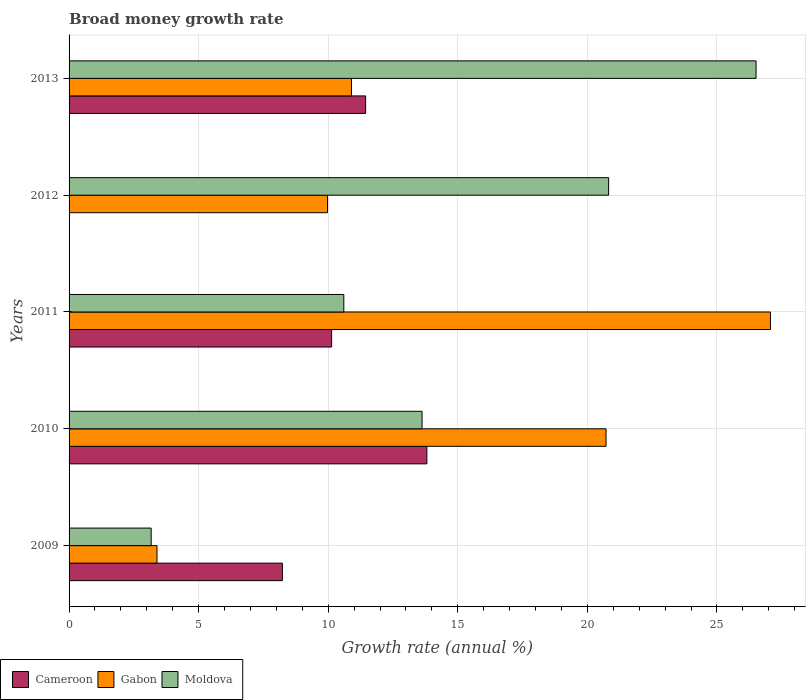How many groups of bars are there?
Keep it short and to the point. 5. Are the number of bars on each tick of the Y-axis equal?
Offer a very short reply. No. How many bars are there on the 5th tick from the top?
Your answer should be very brief. 3. What is the growth rate in Gabon in 2011?
Give a very brief answer. 27.07. Across all years, what is the maximum growth rate in Moldova?
Offer a terse response. 26.51. Across all years, what is the minimum growth rate in Moldova?
Your answer should be compact. 3.17. In which year was the growth rate in Cameroon maximum?
Offer a very short reply. 2010. What is the total growth rate in Gabon in the graph?
Your answer should be very brief. 72.05. What is the difference between the growth rate in Gabon in 2009 and that in 2013?
Your answer should be compact. -7.5. What is the difference between the growth rate in Gabon in 2010 and the growth rate in Cameroon in 2012?
Provide a succinct answer. 20.72. What is the average growth rate in Moldova per year?
Provide a short and direct response. 14.94. In the year 2013, what is the difference between the growth rate in Gabon and growth rate in Cameroon?
Offer a very short reply. -0.55. What is the ratio of the growth rate in Gabon in 2010 to that in 2012?
Your answer should be very brief. 2.08. Is the growth rate in Moldova in 2011 less than that in 2012?
Offer a very short reply. Yes. Is the difference between the growth rate in Gabon in 2009 and 2011 greater than the difference between the growth rate in Cameroon in 2009 and 2011?
Provide a short and direct response. No. What is the difference between the highest and the second highest growth rate in Cameroon?
Ensure brevity in your answer.  2.36. What is the difference between the highest and the lowest growth rate in Cameroon?
Provide a succinct answer. 13.81. In how many years, is the growth rate in Moldova greater than the average growth rate in Moldova taken over all years?
Your answer should be compact. 2. Is it the case that in every year, the sum of the growth rate in Gabon and growth rate in Cameroon is greater than the growth rate in Moldova?
Give a very brief answer. No. How many years are there in the graph?
Your response must be concise. 5. Are the values on the major ticks of X-axis written in scientific E-notation?
Ensure brevity in your answer.  No. Does the graph contain any zero values?
Give a very brief answer. Yes. Does the graph contain grids?
Keep it short and to the point. Yes. Where does the legend appear in the graph?
Ensure brevity in your answer.  Bottom left. How many legend labels are there?
Offer a terse response. 3. What is the title of the graph?
Ensure brevity in your answer.  Broad money growth rate. What is the label or title of the X-axis?
Give a very brief answer. Growth rate (annual %). What is the Growth rate (annual %) of Cameroon in 2009?
Give a very brief answer. 8.23. What is the Growth rate (annual %) of Gabon in 2009?
Make the answer very short. 3.39. What is the Growth rate (annual %) of Moldova in 2009?
Offer a terse response. 3.17. What is the Growth rate (annual %) of Cameroon in 2010?
Your response must be concise. 13.81. What is the Growth rate (annual %) in Gabon in 2010?
Provide a short and direct response. 20.72. What is the Growth rate (annual %) of Moldova in 2010?
Make the answer very short. 13.62. What is the Growth rate (annual %) in Cameroon in 2011?
Your answer should be compact. 10.13. What is the Growth rate (annual %) of Gabon in 2011?
Offer a terse response. 27.07. What is the Growth rate (annual %) in Moldova in 2011?
Your answer should be very brief. 10.6. What is the Growth rate (annual %) of Cameroon in 2012?
Ensure brevity in your answer.  0. What is the Growth rate (annual %) of Gabon in 2012?
Ensure brevity in your answer.  9.97. What is the Growth rate (annual %) in Moldova in 2012?
Provide a succinct answer. 20.82. What is the Growth rate (annual %) of Cameroon in 2013?
Make the answer very short. 11.44. What is the Growth rate (annual %) in Gabon in 2013?
Provide a short and direct response. 10.9. What is the Growth rate (annual %) in Moldova in 2013?
Provide a succinct answer. 26.51. Across all years, what is the maximum Growth rate (annual %) of Cameroon?
Provide a short and direct response. 13.81. Across all years, what is the maximum Growth rate (annual %) in Gabon?
Your response must be concise. 27.07. Across all years, what is the maximum Growth rate (annual %) of Moldova?
Your answer should be compact. 26.51. Across all years, what is the minimum Growth rate (annual %) of Gabon?
Give a very brief answer. 3.39. Across all years, what is the minimum Growth rate (annual %) of Moldova?
Your answer should be compact. 3.17. What is the total Growth rate (annual %) of Cameroon in the graph?
Keep it short and to the point. 43.61. What is the total Growth rate (annual %) in Gabon in the graph?
Make the answer very short. 72.05. What is the total Growth rate (annual %) in Moldova in the graph?
Give a very brief answer. 74.72. What is the difference between the Growth rate (annual %) of Cameroon in 2009 and that in 2010?
Ensure brevity in your answer.  -5.58. What is the difference between the Growth rate (annual %) in Gabon in 2009 and that in 2010?
Ensure brevity in your answer.  -17.33. What is the difference between the Growth rate (annual %) of Moldova in 2009 and that in 2010?
Give a very brief answer. -10.45. What is the difference between the Growth rate (annual %) of Cameroon in 2009 and that in 2011?
Your response must be concise. -1.9. What is the difference between the Growth rate (annual %) of Gabon in 2009 and that in 2011?
Keep it short and to the point. -23.67. What is the difference between the Growth rate (annual %) in Moldova in 2009 and that in 2011?
Make the answer very short. -7.43. What is the difference between the Growth rate (annual %) of Gabon in 2009 and that in 2012?
Your answer should be very brief. -6.58. What is the difference between the Growth rate (annual %) of Moldova in 2009 and that in 2012?
Provide a succinct answer. -17.65. What is the difference between the Growth rate (annual %) in Cameroon in 2009 and that in 2013?
Ensure brevity in your answer.  -3.21. What is the difference between the Growth rate (annual %) in Gabon in 2009 and that in 2013?
Your answer should be compact. -7.5. What is the difference between the Growth rate (annual %) in Moldova in 2009 and that in 2013?
Your answer should be very brief. -23.34. What is the difference between the Growth rate (annual %) of Cameroon in 2010 and that in 2011?
Provide a short and direct response. 3.68. What is the difference between the Growth rate (annual %) of Gabon in 2010 and that in 2011?
Provide a succinct answer. -6.34. What is the difference between the Growth rate (annual %) of Moldova in 2010 and that in 2011?
Offer a terse response. 3.02. What is the difference between the Growth rate (annual %) in Gabon in 2010 and that in 2012?
Your answer should be very brief. 10.75. What is the difference between the Growth rate (annual %) in Moldova in 2010 and that in 2012?
Offer a terse response. -7.2. What is the difference between the Growth rate (annual %) in Cameroon in 2010 and that in 2013?
Provide a short and direct response. 2.36. What is the difference between the Growth rate (annual %) in Gabon in 2010 and that in 2013?
Make the answer very short. 9.83. What is the difference between the Growth rate (annual %) in Moldova in 2010 and that in 2013?
Provide a short and direct response. -12.89. What is the difference between the Growth rate (annual %) of Gabon in 2011 and that in 2012?
Give a very brief answer. 17.09. What is the difference between the Growth rate (annual %) in Moldova in 2011 and that in 2012?
Your answer should be compact. -10.22. What is the difference between the Growth rate (annual %) of Cameroon in 2011 and that in 2013?
Offer a very short reply. -1.31. What is the difference between the Growth rate (annual %) of Gabon in 2011 and that in 2013?
Provide a short and direct response. 16.17. What is the difference between the Growth rate (annual %) in Moldova in 2011 and that in 2013?
Your response must be concise. -15.91. What is the difference between the Growth rate (annual %) of Gabon in 2012 and that in 2013?
Make the answer very short. -0.92. What is the difference between the Growth rate (annual %) in Moldova in 2012 and that in 2013?
Provide a succinct answer. -5.69. What is the difference between the Growth rate (annual %) in Cameroon in 2009 and the Growth rate (annual %) in Gabon in 2010?
Keep it short and to the point. -12.49. What is the difference between the Growth rate (annual %) in Cameroon in 2009 and the Growth rate (annual %) in Moldova in 2010?
Offer a very short reply. -5.39. What is the difference between the Growth rate (annual %) in Gabon in 2009 and the Growth rate (annual %) in Moldova in 2010?
Your answer should be very brief. -10.23. What is the difference between the Growth rate (annual %) in Cameroon in 2009 and the Growth rate (annual %) in Gabon in 2011?
Offer a very short reply. -18.83. What is the difference between the Growth rate (annual %) of Cameroon in 2009 and the Growth rate (annual %) of Moldova in 2011?
Provide a short and direct response. -2.37. What is the difference between the Growth rate (annual %) of Gabon in 2009 and the Growth rate (annual %) of Moldova in 2011?
Keep it short and to the point. -7.21. What is the difference between the Growth rate (annual %) in Cameroon in 2009 and the Growth rate (annual %) in Gabon in 2012?
Provide a succinct answer. -1.74. What is the difference between the Growth rate (annual %) in Cameroon in 2009 and the Growth rate (annual %) in Moldova in 2012?
Your answer should be very brief. -12.59. What is the difference between the Growth rate (annual %) in Gabon in 2009 and the Growth rate (annual %) in Moldova in 2012?
Provide a succinct answer. -17.43. What is the difference between the Growth rate (annual %) in Cameroon in 2009 and the Growth rate (annual %) in Gabon in 2013?
Your response must be concise. -2.67. What is the difference between the Growth rate (annual %) in Cameroon in 2009 and the Growth rate (annual %) in Moldova in 2013?
Offer a terse response. -18.28. What is the difference between the Growth rate (annual %) in Gabon in 2009 and the Growth rate (annual %) in Moldova in 2013?
Provide a short and direct response. -23.12. What is the difference between the Growth rate (annual %) of Cameroon in 2010 and the Growth rate (annual %) of Gabon in 2011?
Offer a very short reply. -13.26. What is the difference between the Growth rate (annual %) of Cameroon in 2010 and the Growth rate (annual %) of Moldova in 2011?
Your answer should be very brief. 3.2. What is the difference between the Growth rate (annual %) in Gabon in 2010 and the Growth rate (annual %) in Moldova in 2011?
Offer a terse response. 10.12. What is the difference between the Growth rate (annual %) of Cameroon in 2010 and the Growth rate (annual %) of Gabon in 2012?
Your response must be concise. 3.83. What is the difference between the Growth rate (annual %) in Cameroon in 2010 and the Growth rate (annual %) in Moldova in 2012?
Provide a short and direct response. -7.01. What is the difference between the Growth rate (annual %) in Gabon in 2010 and the Growth rate (annual %) in Moldova in 2012?
Your answer should be very brief. -0.1. What is the difference between the Growth rate (annual %) of Cameroon in 2010 and the Growth rate (annual %) of Gabon in 2013?
Provide a short and direct response. 2.91. What is the difference between the Growth rate (annual %) in Cameroon in 2010 and the Growth rate (annual %) in Moldova in 2013?
Keep it short and to the point. -12.7. What is the difference between the Growth rate (annual %) in Gabon in 2010 and the Growth rate (annual %) in Moldova in 2013?
Your answer should be very brief. -5.79. What is the difference between the Growth rate (annual %) in Cameroon in 2011 and the Growth rate (annual %) in Gabon in 2012?
Make the answer very short. 0.16. What is the difference between the Growth rate (annual %) in Cameroon in 2011 and the Growth rate (annual %) in Moldova in 2012?
Ensure brevity in your answer.  -10.69. What is the difference between the Growth rate (annual %) of Gabon in 2011 and the Growth rate (annual %) of Moldova in 2012?
Provide a short and direct response. 6.24. What is the difference between the Growth rate (annual %) in Cameroon in 2011 and the Growth rate (annual %) in Gabon in 2013?
Ensure brevity in your answer.  -0.77. What is the difference between the Growth rate (annual %) in Cameroon in 2011 and the Growth rate (annual %) in Moldova in 2013?
Offer a very short reply. -16.38. What is the difference between the Growth rate (annual %) in Gabon in 2011 and the Growth rate (annual %) in Moldova in 2013?
Provide a short and direct response. 0.55. What is the difference between the Growth rate (annual %) of Gabon in 2012 and the Growth rate (annual %) of Moldova in 2013?
Keep it short and to the point. -16.54. What is the average Growth rate (annual %) of Cameroon per year?
Your answer should be very brief. 8.72. What is the average Growth rate (annual %) of Gabon per year?
Your answer should be very brief. 14.41. What is the average Growth rate (annual %) in Moldova per year?
Provide a short and direct response. 14.94. In the year 2009, what is the difference between the Growth rate (annual %) of Cameroon and Growth rate (annual %) of Gabon?
Make the answer very short. 4.84. In the year 2009, what is the difference between the Growth rate (annual %) in Cameroon and Growth rate (annual %) in Moldova?
Provide a short and direct response. 5.06. In the year 2009, what is the difference between the Growth rate (annual %) of Gabon and Growth rate (annual %) of Moldova?
Provide a succinct answer. 0.23. In the year 2010, what is the difference between the Growth rate (annual %) in Cameroon and Growth rate (annual %) in Gabon?
Give a very brief answer. -6.92. In the year 2010, what is the difference between the Growth rate (annual %) in Cameroon and Growth rate (annual %) in Moldova?
Your answer should be very brief. 0.18. In the year 2010, what is the difference between the Growth rate (annual %) of Gabon and Growth rate (annual %) of Moldova?
Ensure brevity in your answer.  7.1. In the year 2011, what is the difference between the Growth rate (annual %) in Cameroon and Growth rate (annual %) in Gabon?
Your answer should be very brief. -16.93. In the year 2011, what is the difference between the Growth rate (annual %) in Cameroon and Growth rate (annual %) in Moldova?
Keep it short and to the point. -0.47. In the year 2011, what is the difference between the Growth rate (annual %) of Gabon and Growth rate (annual %) of Moldova?
Ensure brevity in your answer.  16.46. In the year 2012, what is the difference between the Growth rate (annual %) in Gabon and Growth rate (annual %) in Moldova?
Keep it short and to the point. -10.85. In the year 2013, what is the difference between the Growth rate (annual %) of Cameroon and Growth rate (annual %) of Gabon?
Make the answer very short. 0.55. In the year 2013, what is the difference between the Growth rate (annual %) of Cameroon and Growth rate (annual %) of Moldova?
Provide a succinct answer. -15.07. In the year 2013, what is the difference between the Growth rate (annual %) of Gabon and Growth rate (annual %) of Moldova?
Your answer should be compact. -15.61. What is the ratio of the Growth rate (annual %) of Cameroon in 2009 to that in 2010?
Provide a short and direct response. 0.6. What is the ratio of the Growth rate (annual %) in Gabon in 2009 to that in 2010?
Give a very brief answer. 0.16. What is the ratio of the Growth rate (annual %) of Moldova in 2009 to that in 2010?
Provide a short and direct response. 0.23. What is the ratio of the Growth rate (annual %) in Cameroon in 2009 to that in 2011?
Keep it short and to the point. 0.81. What is the ratio of the Growth rate (annual %) in Gabon in 2009 to that in 2011?
Make the answer very short. 0.13. What is the ratio of the Growth rate (annual %) in Moldova in 2009 to that in 2011?
Offer a very short reply. 0.3. What is the ratio of the Growth rate (annual %) of Gabon in 2009 to that in 2012?
Provide a short and direct response. 0.34. What is the ratio of the Growth rate (annual %) of Moldova in 2009 to that in 2012?
Provide a short and direct response. 0.15. What is the ratio of the Growth rate (annual %) in Cameroon in 2009 to that in 2013?
Give a very brief answer. 0.72. What is the ratio of the Growth rate (annual %) in Gabon in 2009 to that in 2013?
Keep it short and to the point. 0.31. What is the ratio of the Growth rate (annual %) in Moldova in 2009 to that in 2013?
Your response must be concise. 0.12. What is the ratio of the Growth rate (annual %) of Cameroon in 2010 to that in 2011?
Make the answer very short. 1.36. What is the ratio of the Growth rate (annual %) of Gabon in 2010 to that in 2011?
Your answer should be compact. 0.77. What is the ratio of the Growth rate (annual %) in Moldova in 2010 to that in 2011?
Your answer should be compact. 1.28. What is the ratio of the Growth rate (annual %) in Gabon in 2010 to that in 2012?
Provide a short and direct response. 2.08. What is the ratio of the Growth rate (annual %) of Moldova in 2010 to that in 2012?
Make the answer very short. 0.65. What is the ratio of the Growth rate (annual %) of Cameroon in 2010 to that in 2013?
Give a very brief answer. 1.21. What is the ratio of the Growth rate (annual %) in Gabon in 2010 to that in 2013?
Your response must be concise. 1.9. What is the ratio of the Growth rate (annual %) of Moldova in 2010 to that in 2013?
Make the answer very short. 0.51. What is the ratio of the Growth rate (annual %) of Gabon in 2011 to that in 2012?
Offer a terse response. 2.71. What is the ratio of the Growth rate (annual %) in Moldova in 2011 to that in 2012?
Provide a short and direct response. 0.51. What is the ratio of the Growth rate (annual %) in Cameroon in 2011 to that in 2013?
Give a very brief answer. 0.89. What is the ratio of the Growth rate (annual %) in Gabon in 2011 to that in 2013?
Provide a succinct answer. 2.48. What is the ratio of the Growth rate (annual %) in Moldova in 2011 to that in 2013?
Offer a very short reply. 0.4. What is the ratio of the Growth rate (annual %) of Gabon in 2012 to that in 2013?
Make the answer very short. 0.92. What is the ratio of the Growth rate (annual %) of Moldova in 2012 to that in 2013?
Make the answer very short. 0.79. What is the difference between the highest and the second highest Growth rate (annual %) of Cameroon?
Provide a short and direct response. 2.36. What is the difference between the highest and the second highest Growth rate (annual %) of Gabon?
Offer a terse response. 6.34. What is the difference between the highest and the second highest Growth rate (annual %) of Moldova?
Your response must be concise. 5.69. What is the difference between the highest and the lowest Growth rate (annual %) in Cameroon?
Your response must be concise. 13.81. What is the difference between the highest and the lowest Growth rate (annual %) in Gabon?
Your response must be concise. 23.67. What is the difference between the highest and the lowest Growth rate (annual %) in Moldova?
Give a very brief answer. 23.34. 